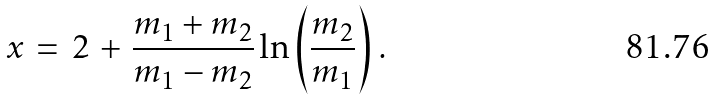Convert formula to latex. <formula><loc_0><loc_0><loc_500><loc_500>x \, = \, 2 \, + \, \frac { m _ { 1 } + m _ { 2 } } { m _ { 1 } - m _ { 2 } } \ln \left ( \frac { m _ { 2 } } { m _ { 1 } } \right ) \, .</formula> 